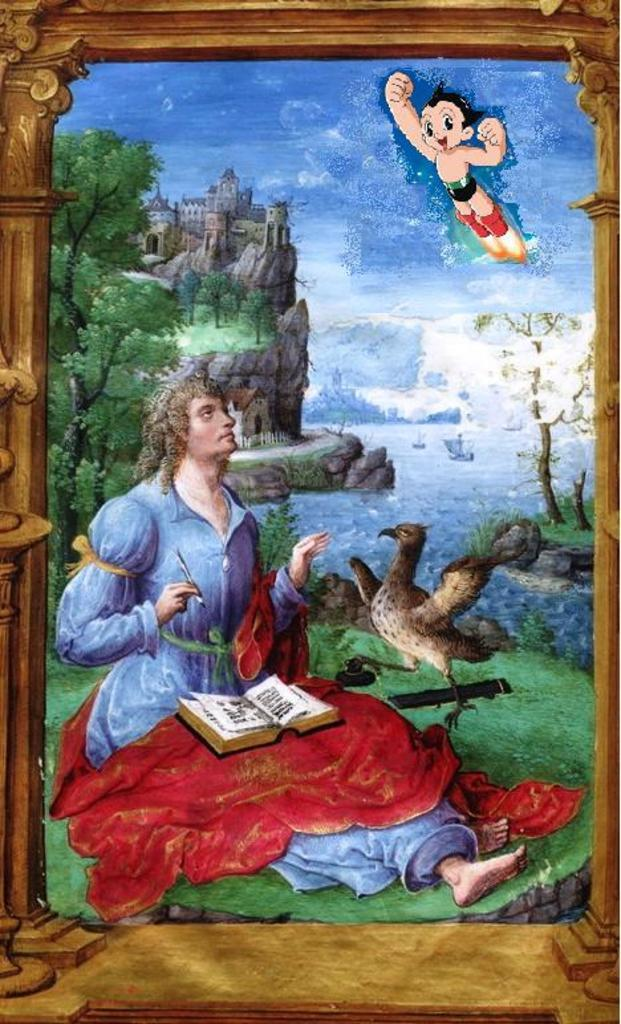Who is depicted in the painting? There is a man in the painting. What other living creature can be seen in the painting? There is a bird in the painting. What object is present in the painting? There is a book in the painting. What type of natural environment is shown in the painting? There are trees and a sky in the painting. How many crackers are being eaten by the horse in the painting? There is no horse present in the painting, and therefore no crackers being eaten. What is the digestive system of the bird in the painting? The painting does not provide information about the bird's digestive system. 